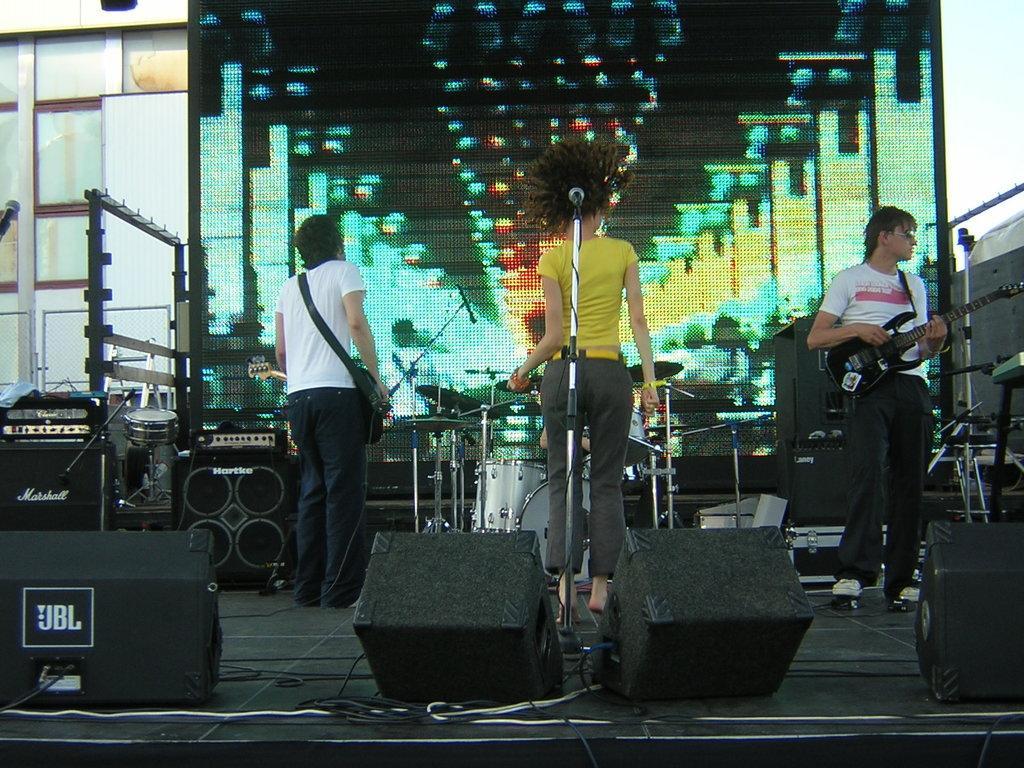In one or two sentences, can you explain what this image depicts? In this image we can see two people standing and holding guitars. The lady standing in the center is performing. We can see a mic placed on the stand. In the background there is a band, screen and a wall. At the bottom there are speakers. 